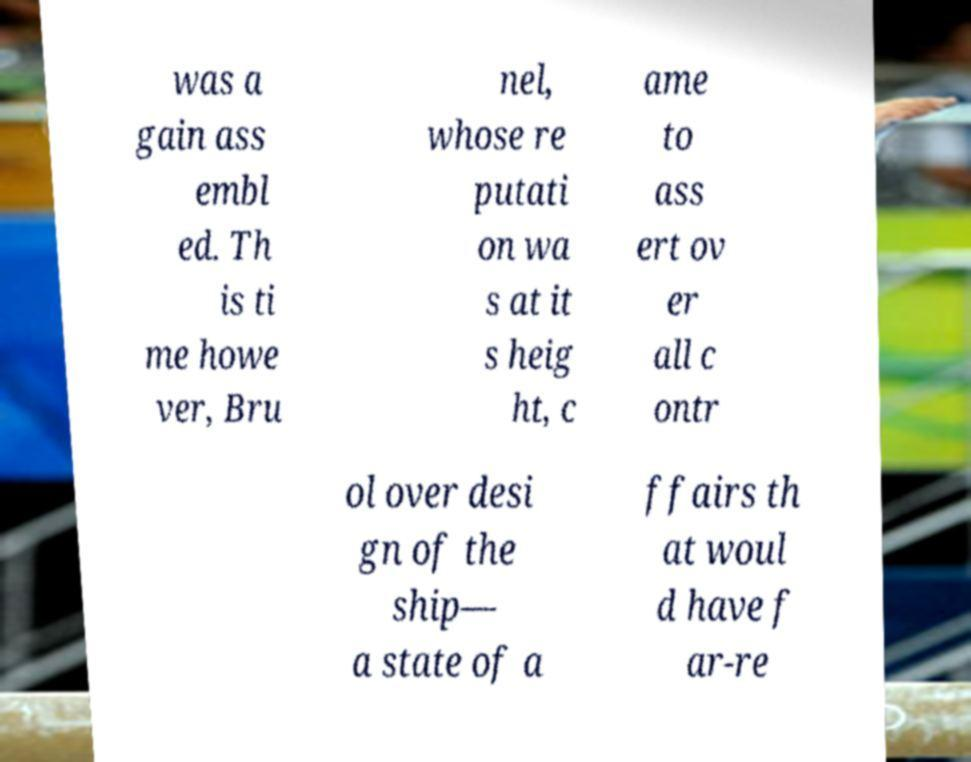What messages or text are displayed in this image? I need them in a readable, typed format. was a gain ass embl ed. Th is ti me howe ver, Bru nel, whose re putati on wa s at it s heig ht, c ame to ass ert ov er all c ontr ol over desi gn of the ship— a state of a ffairs th at woul d have f ar-re 